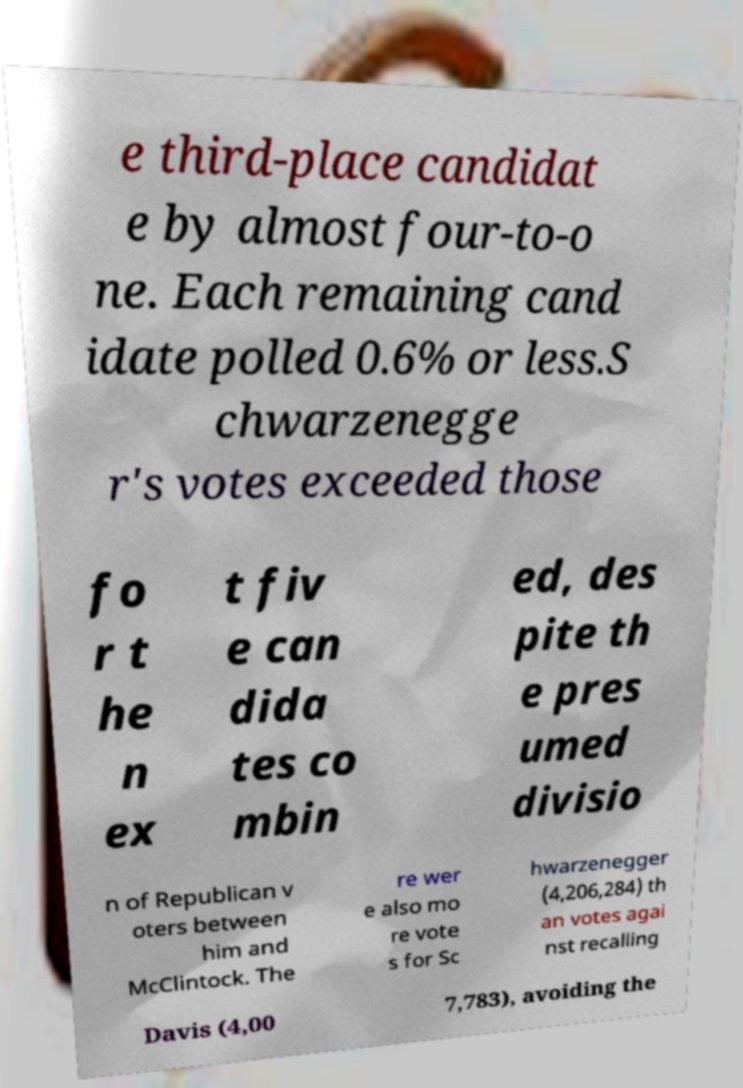Can you read and provide the text displayed in the image?This photo seems to have some interesting text. Can you extract and type it out for me? e third-place candidat e by almost four-to-o ne. Each remaining cand idate polled 0.6% or less.S chwarzenegge r's votes exceeded those fo r t he n ex t fiv e can dida tes co mbin ed, des pite th e pres umed divisio n of Republican v oters between him and McClintock. The re wer e also mo re vote s for Sc hwarzenegger (4,206,284) th an votes agai nst recalling Davis (4,00 7,783), avoiding the 